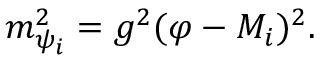Convert formula to latex. <formula><loc_0><loc_0><loc_500><loc_500>m _ { \psi _ { i } } ^ { 2 } = g ^ { 2 } ( \varphi - M _ { i } ) ^ { 2 } .</formula> 